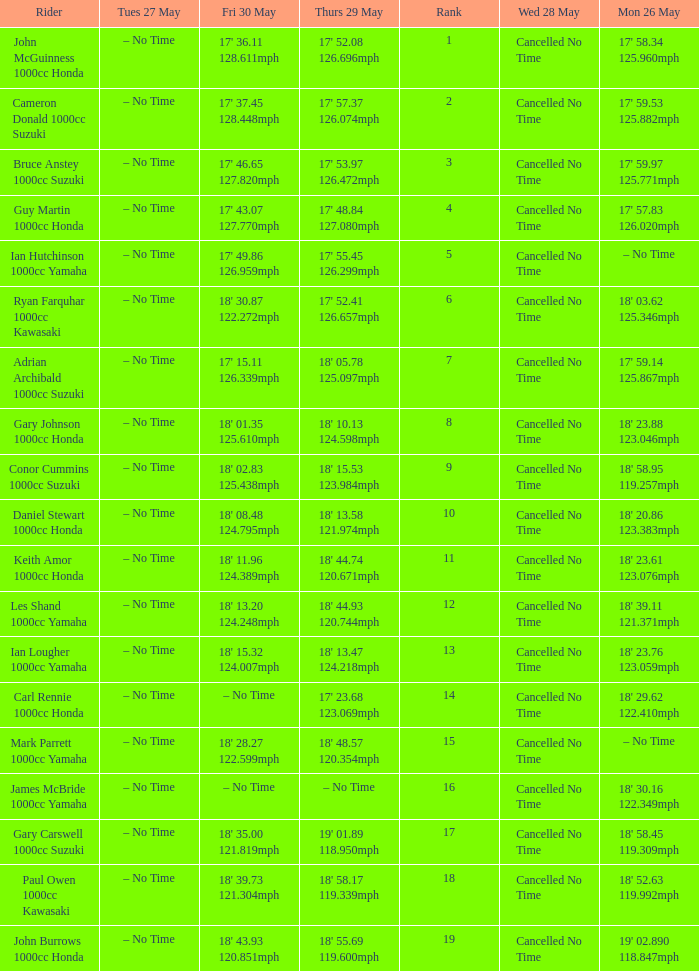What is the numbr for fri may 30 and mon may 26 is 19' 02.890 118.847mph? 18' 43.93 120.851mph. Write the full table. {'header': ['Rider', 'Tues 27 May', 'Fri 30 May', 'Thurs 29 May', 'Rank', 'Wed 28 May', 'Mon 26 May'], 'rows': [['John McGuinness 1000cc Honda', '– No Time', "17' 36.11 128.611mph", "17' 52.08 126.696mph", '1', 'Cancelled No Time', "17' 58.34 125.960mph"], ['Cameron Donald 1000cc Suzuki', '– No Time', "17' 37.45 128.448mph", "17' 57.37 126.074mph", '2', 'Cancelled No Time', "17' 59.53 125.882mph"], ['Bruce Anstey 1000cc Suzuki', '– No Time', "17' 46.65 127.820mph", "17' 53.97 126.472mph", '3', 'Cancelled No Time', "17' 59.97 125.771mph"], ['Guy Martin 1000cc Honda', '– No Time', "17' 43.07 127.770mph", "17' 48.84 127.080mph", '4', 'Cancelled No Time', "17' 57.83 126.020mph"], ['Ian Hutchinson 1000cc Yamaha', '– No Time', "17' 49.86 126.959mph", "17' 55.45 126.299mph", '5', 'Cancelled No Time', '– No Time'], ['Ryan Farquhar 1000cc Kawasaki', '– No Time', "18' 30.87 122.272mph", "17' 52.41 126.657mph", '6', 'Cancelled No Time', "18' 03.62 125.346mph"], ['Adrian Archibald 1000cc Suzuki', '– No Time', "17' 15.11 126.339mph", "18' 05.78 125.097mph", '7', 'Cancelled No Time', "17' 59.14 125.867mph"], ['Gary Johnson 1000cc Honda', '– No Time', "18' 01.35 125.610mph", "18' 10.13 124.598mph", '8', 'Cancelled No Time', "18' 23.88 123.046mph"], ['Conor Cummins 1000cc Suzuki', '– No Time', "18' 02.83 125.438mph", "18' 15.53 123.984mph", '9', 'Cancelled No Time', "18' 58.95 119.257mph"], ['Daniel Stewart 1000cc Honda', '– No Time', "18' 08.48 124.795mph", "18' 13.58 121.974mph", '10', 'Cancelled No Time', "18' 20.86 123.383mph"], ['Keith Amor 1000cc Honda', '– No Time', "18' 11.96 124.389mph", "18' 44.74 120.671mph", '11', 'Cancelled No Time', "18' 23.61 123.076mph"], ['Les Shand 1000cc Yamaha', '– No Time', "18' 13.20 124.248mph", "18' 44.93 120.744mph", '12', 'Cancelled No Time', "18' 39.11 121.371mph"], ['Ian Lougher 1000cc Yamaha', '– No Time', "18' 15.32 124.007mph", "18' 13.47 124.218mph", '13', 'Cancelled No Time', "18' 23.76 123.059mph"], ['Carl Rennie 1000cc Honda', '– No Time', '– No Time', "17' 23.68 123.069mph", '14', 'Cancelled No Time', "18' 29.62 122.410mph"], ['Mark Parrett 1000cc Yamaha', '– No Time', "18' 28.27 122.599mph", "18' 48.57 120.354mph", '15', 'Cancelled No Time', '– No Time'], ['James McBride 1000cc Yamaha', '– No Time', '– No Time', '– No Time', '16', 'Cancelled No Time', "18' 30.16 122.349mph"], ['Gary Carswell 1000cc Suzuki', '– No Time', "18' 35.00 121.819mph", "19' 01.89 118.950mph", '17', 'Cancelled No Time', "18' 58.45 119.309mph"], ['Paul Owen 1000cc Kawasaki', '– No Time', "18' 39.73 121.304mph", "18' 58.17 119.339mph", '18', 'Cancelled No Time', "18' 52.63 119.992mph"], ['John Burrows 1000cc Honda', '– No Time', "18' 43.93 120.851mph", "18' 55.69 119.600mph", '19', 'Cancelled No Time', "19' 02.890 118.847mph"]]} 